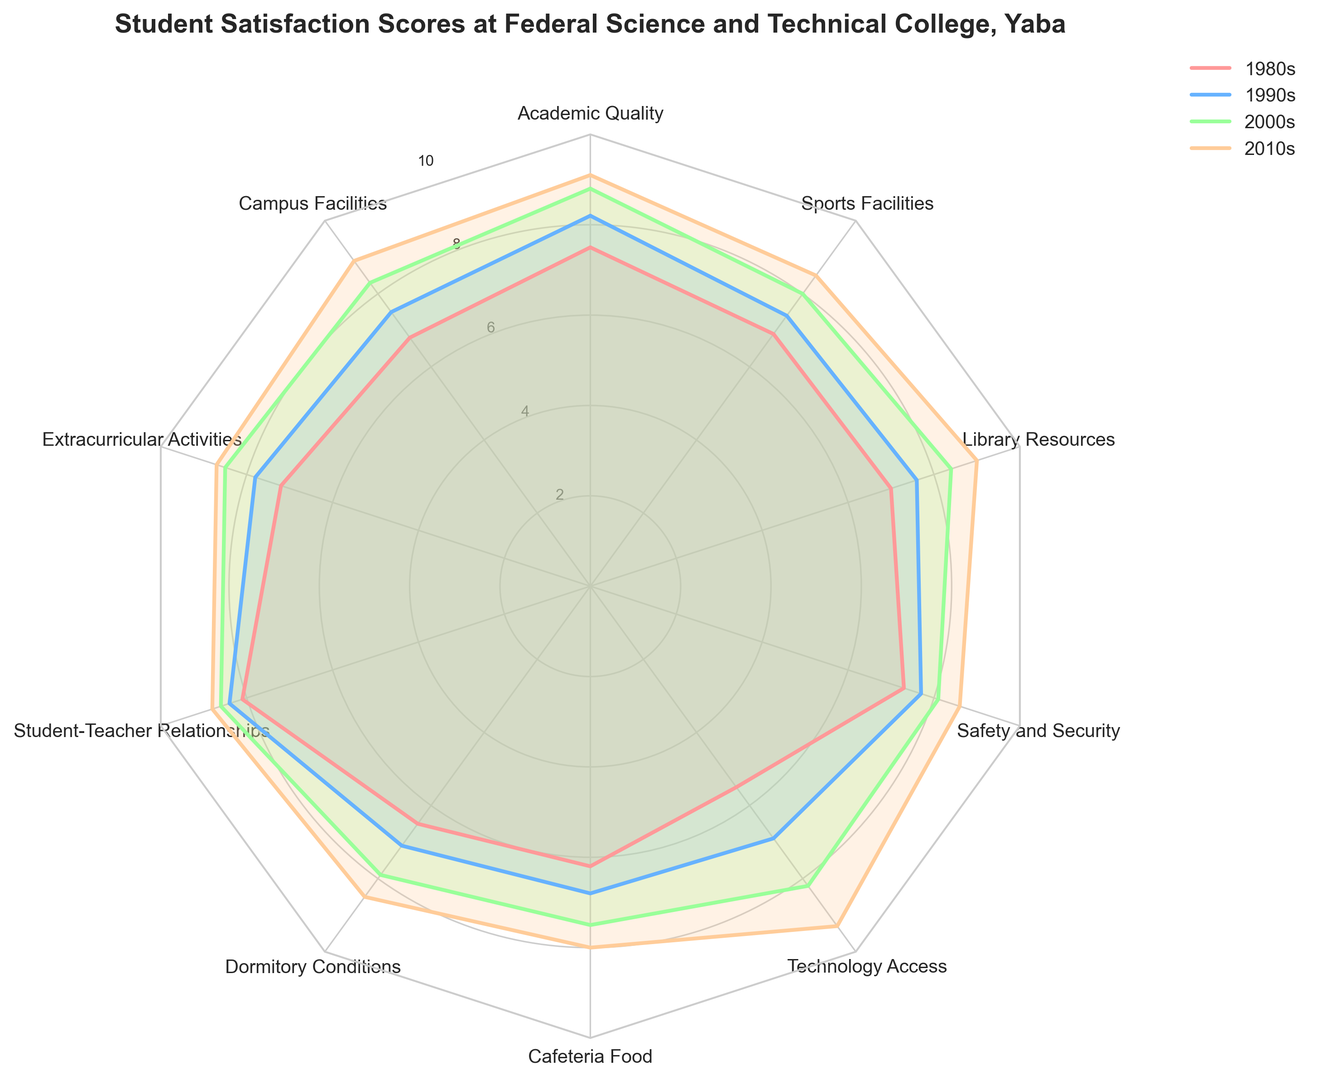Which decade has the highest overall satisfaction score for Technology Access? Look at the radial plot lines for Technology Access and see which decade has the highest value.
Answer: 2010s Compare the satisfaction scores for Dormitory Conditions between the 1980s and 2000s. Which decade shows greater improvement relative to its previous decade? Check the scores for the 1980s (6.5), 1990s (7.1), 2000s (7.9), and calculate the difference between successive decades for Dormitory Conditions. The improvement from 1980s to 1990s is (7.1 - 6.5) = 0.6, and from 1990s to 2000s is (7.9 - 7.1) = 0.8.
Answer: 2000s What is the difference in satisfaction scores for Academic Quality between the 1990s and 2010s? Subtract the score for the 1990s from the score for the 2010s for Academic Quality. 9.1 - 8.2 = 0.9.
Answer: 0.9 Which decade has the lowest score for Cafeteria Food, and what is the score? Identify the lowest value on the radial plot lines for Cafeteria Food.
Answer: 1980s, 6.2 How do the satisfaction scores for Extracurricular Activities change from the 2000s to the 2010s? Look at the plot values for Extracurricular Activities in the 2000s and 2010s and compare them. The scores are 8.5 in the 2000s and 8.7 in the 2010s.
Answer: The scores increased from 8.5 to 8.7 Which aspect has the highest satisfaction score in the 2010s, and what is the value? Find the maximum value for the 2010s across all aspects on the radar chart.
Answer: Technology Access, 9.3 What is the average satisfaction score for Student-Teacher Relationships across all decades? Sum the Student-Teacher Relationships scores for all decades: 8.1 + 8.4 + 8.6 + 8.8, then divide by 4. (8.1 + 8.4 + 8.6 + 8.8) / 4 = 8.475.
Answer: 8.475 Compare the 1980s and 2010s scores for Safety and Security. How much did it improve? Subtract the 1980s score for Safety and Security from the 2010s score. 8.6 - 7.3 = 1.3.
Answer: 1.3 Between Academic Quality and Campus Facilities in the 2000s, which aspect had a higher satisfaction score? Check and compare the values for Academic Quality and Campus Facilities in the 2000s. Academic Quality is 8.8 and Campus Facilities is 8.3.
Answer: Academic Quality Considering Library Resources, what has been the trend in satisfaction scores from the 1980s to the 2010s? Observe the plotted values for Library Resources: 1980s (7.0), 1990s (7.6), 2000s (8.4), 2010s (9.0). Satisfaction has been steadily increasing.
Answer: Increasing trend 